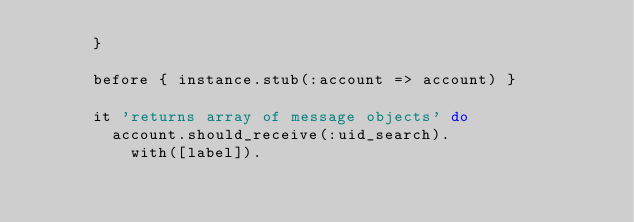<code> <loc_0><loc_0><loc_500><loc_500><_Ruby_>      }

      before { instance.stub(:account => account) }

      it 'returns array of message objects' do
        account.should_receive(:uid_search).
          with([label]).</code> 